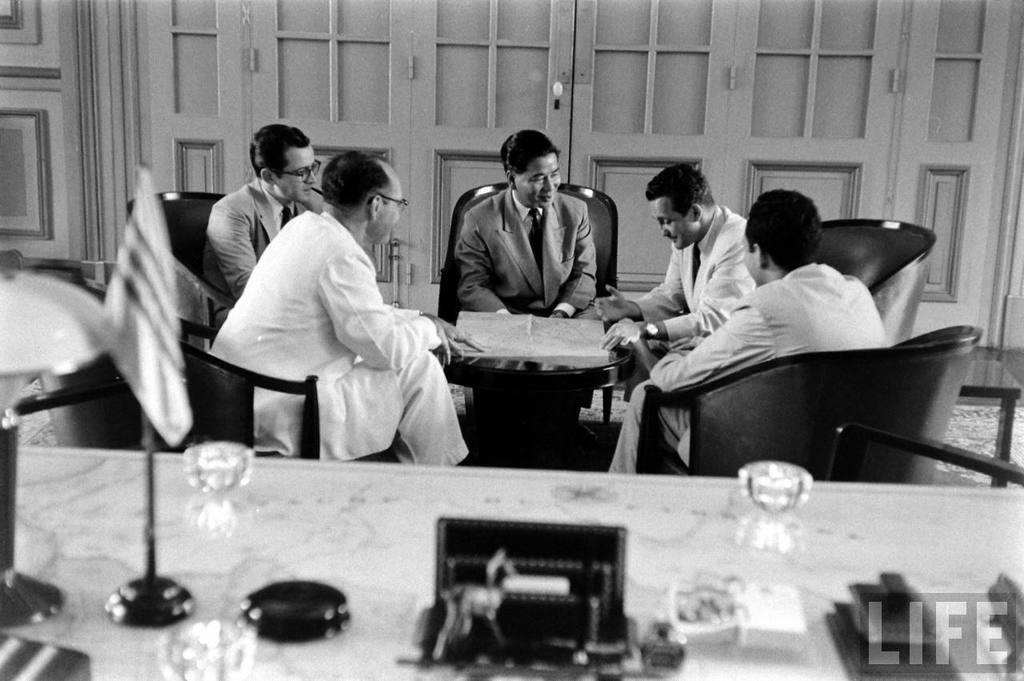What is the color scheme of the image? The image is black and white. What are the persons in the image doing? The persons are sitting on a chair. What is in front of the persons? There is a table in front of the persons. What is on the table? There is a chart, a flag, and other things on the table. How many women are present in the image? The provided facts do not mention the gender of the persons in the image, so it is impossible to determine the number of women present. Is there a shelf visible in the image? There is no mention of a shelf in the provided facts, so it cannot be determined if one is present in the image. 